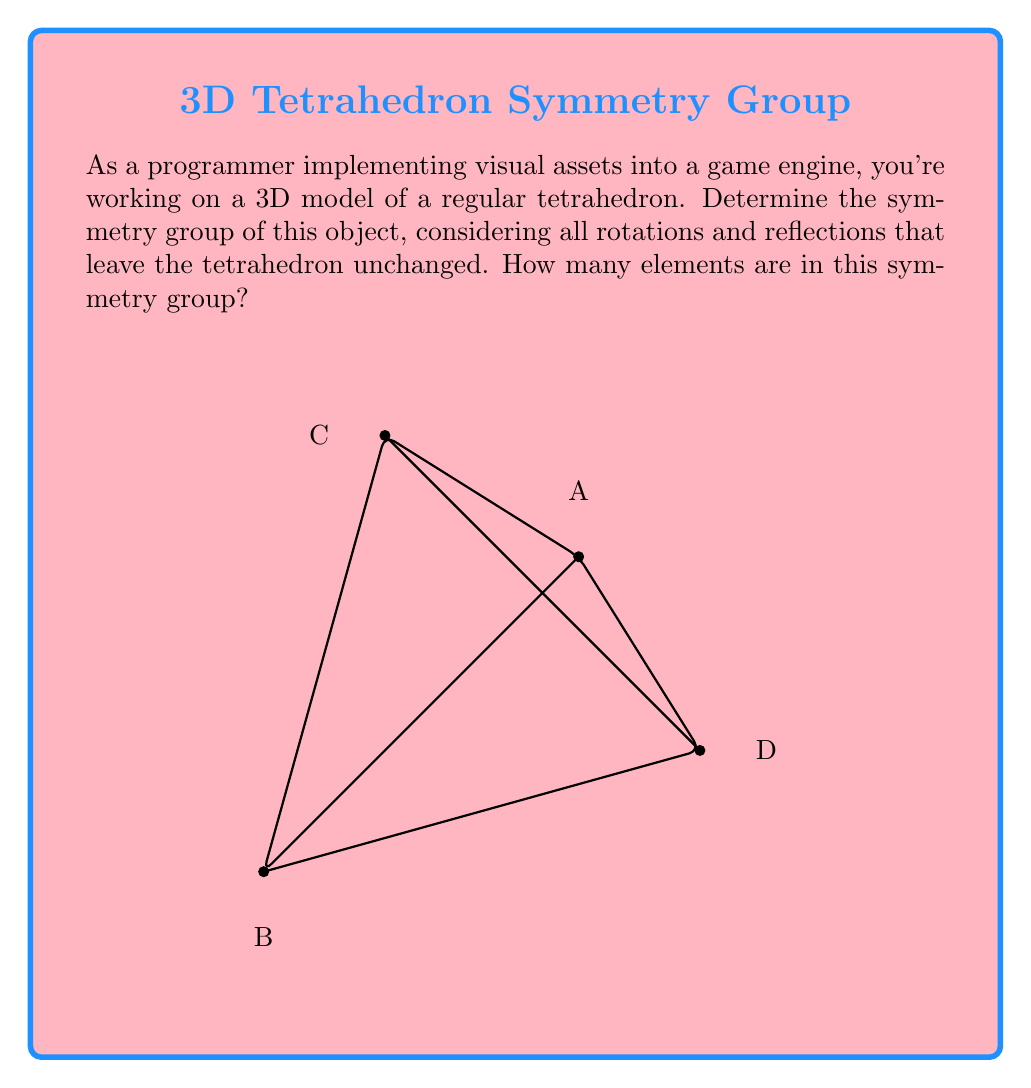Can you answer this question? To determine the symmetry group of a regular tetrahedron, we need to consider all the operations that leave the tetrahedron unchanged. Let's approach this step-by-step:

1) Rotational symmetries:
   a) Identity (1)
   b) Rotations by 120° and 240° around each of the 4 vertex-to-opposite-face axes (8)
   c) Rotations by 180° around each of the 3 axes connecting midpoints of opposite edges (3)
   Total rotational symmetries: 1 + 8 + 3 = 12

2) Reflectional symmetries:
   a) Reflections across 6 planes, each containing an edge and bisecting the opposite edge (6)

3) Total number of symmetries:
   12 (rotations) + 6 (reflections) = 18

The symmetry group of a regular tetrahedron is isomorphic to the symmetric group $S_4$, which permutes the 4 vertices of the tetrahedron. This group is also known as the tetrahedral group, often denoted as $T_d$.

The order of this group is 24, which can be calculated using the formula $n!$ where $n$ is the number of vertices (4! = 24).

It's worth noting that in 3D computer graphics, we typically only consider proper rotations (no reflections) to preserve the orientation of the object. In this case, we would use the rotation group, which is a subgroup of the full symmetry group and has 12 elements.
Answer: 24 